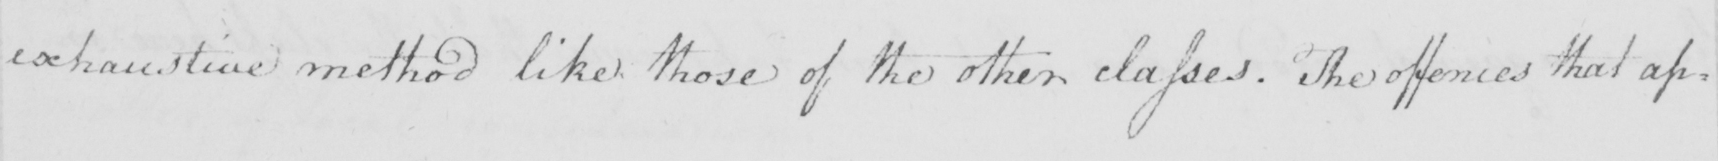What text is written in this handwritten line? exhaustive method like those of the other classes . The offences that ap : 